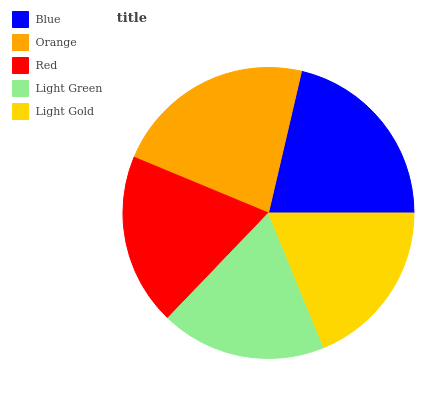Is Light Green the minimum?
Answer yes or no. Yes. Is Orange the maximum?
Answer yes or no. Yes. Is Red the minimum?
Answer yes or no. No. Is Red the maximum?
Answer yes or no. No. Is Orange greater than Red?
Answer yes or no. Yes. Is Red less than Orange?
Answer yes or no. Yes. Is Red greater than Orange?
Answer yes or no. No. Is Orange less than Red?
Answer yes or no. No. Is Red the high median?
Answer yes or no. Yes. Is Red the low median?
Answer yes or no. Yes. Is Orange the high median?
Answer yes or no. No. Is Orange the low median?
Answer yes or no. No. 